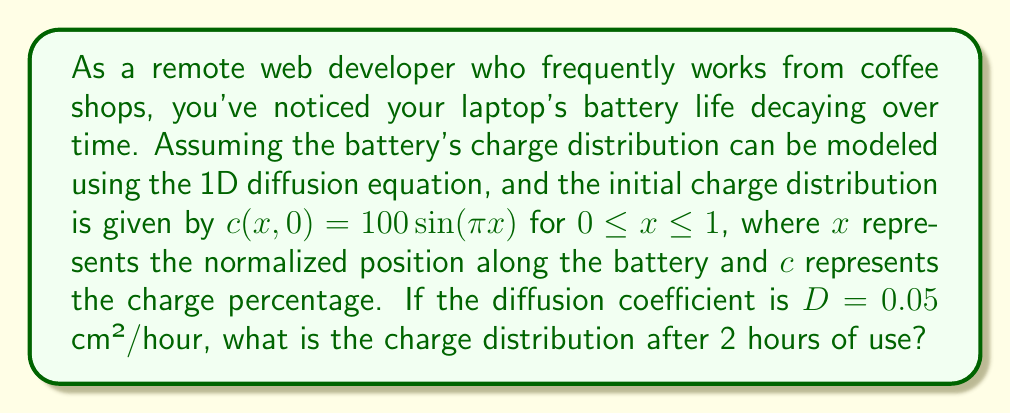What is the answer to this math problem? To solve this problem, we need to use the 1D diffusion equation and apply the given initial condition. The diffusion equation is:

$$\frac{\partial c}{\partial t} = D\frac{\partial^2 c}{\partial x^2}$$

Where $c(x,t)$ is the charge distribution, $t$ is time, and $D$ is the diffusion coefficient.

Given:
- Initial condition: $c(x,0) = 100\sin(\pi x)$ for $0 \leq x \leq 1$
- Diffusion coefficient: $D = 0.05$ cm²/hour
- Time: $t = 2$ hours

The solution to the diffusion equation with these conditions is of the form:

$$c(x,t) = Ae^{-\lambda^2Dt}\sin(\lambda x)$$

Where $A$ is the amplitude and $\lambda$ is the wave number.

From the initial condition, we can determine that $A = 100$ and $\lambda = \pi$.

Substituting these values:

$$c(x,t) = 100e^{-\pi^2Dt}\sin(\pi x)$$

Now, we can calculate the charge distribution after 2 hours by substituting $t = 2$ and $D = 0.05$:

$$c(x,2) = 100e^{-\pi^2 \cdot 0.05 \cdot 2}\sin(\pi x)$$
$$c(x,2) = 100e^{-0.1\pi^2}\sin(\pi x)$$
$$c(x,2) \approx 37.0\sin(\pi x)$$

This equation represents the charge distribution along the battery after 2 hours of use.
Answer: $c(x,2) \approx 37.0\sin(\pi x)$ for $0 \leq x \leq 1$ 